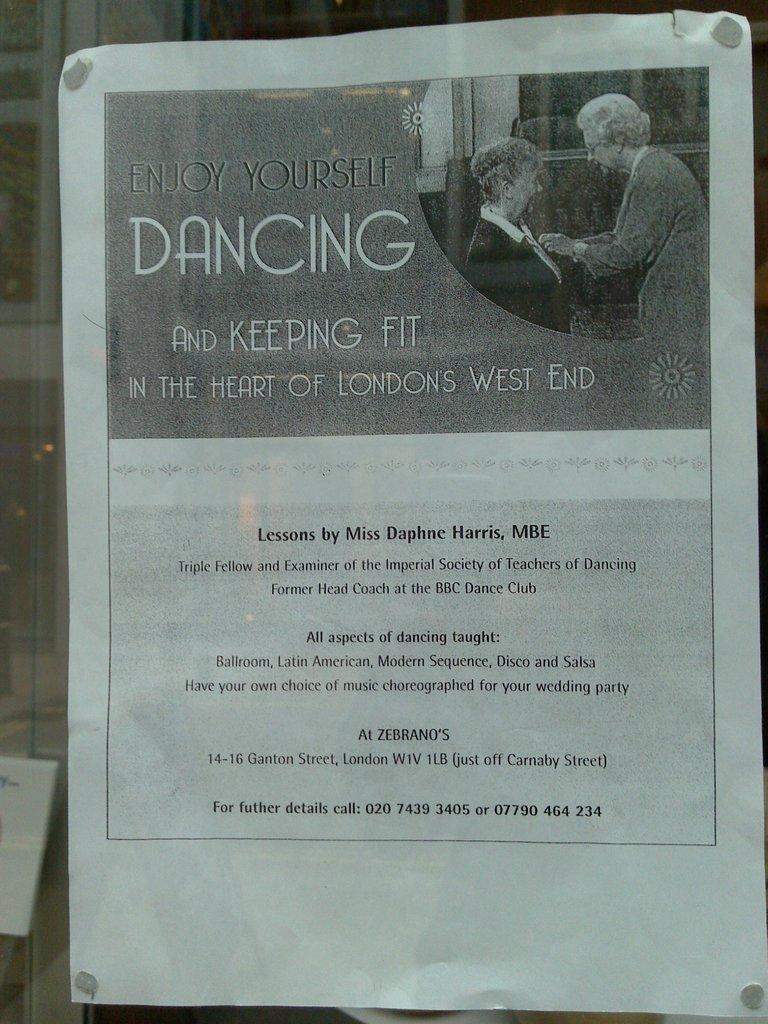Can you describe this image briefly? In the image we can see a poster. 